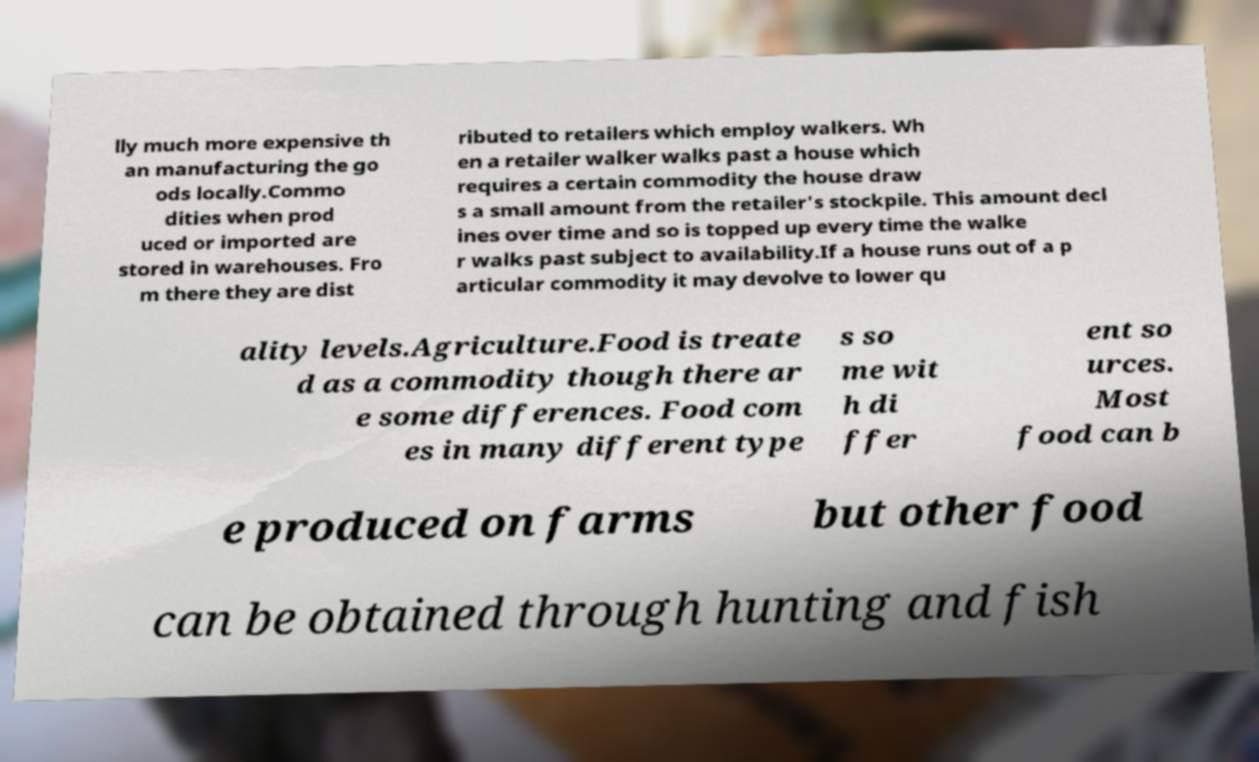There's text embedded in this image that I need extracted. Can you transcribe it verbatim? lly much more expensive th an manufacturing the go ods locally.Commo dities when prod uced or imported are stored in warehouses. Fro m there they are dist ributed to retailers which employ walkers. Wh en a retailer walker walks past a house which requires a certain commodity the house draw s a small amount from the retailer's stockpile. This amount decl ines over time and so is topped up every time the walke r walks past subject to availability.If a house runs out of a p articular commodity it may devolve to lower qu ality levels.Agriculture.Food is treate d as a commodity though there ar e some differences. Food com es in many different type s so me wit h di ffer ent so urces. Most food can b e produced on farms but other food can be obtained through hunting and fish 